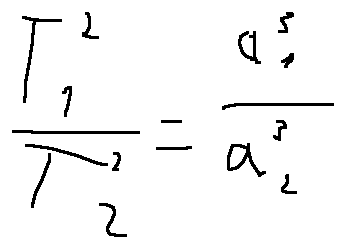<formula> <loc_0><loc_0><loc_500><loc_500>\frac { T _ { 1 } ^ { 2 } } { T _ { 2 } ^ { 2 } } = \frac { a _ { 1 } ^ { 3 } } { a _ { 2 } ^ { 3 } }</formula> 